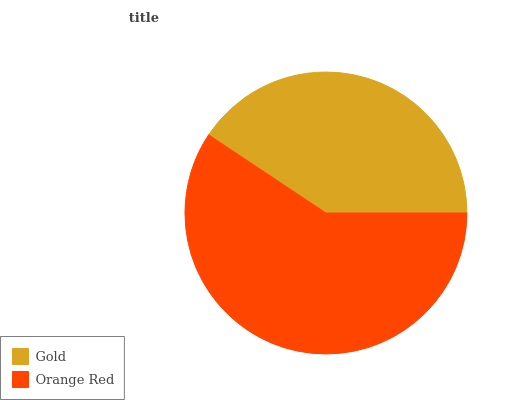Is Gold the minimum?
Answer yes or no. Yes. Is Orange Red the maximum?
Answer yes or no. Yes. Is Orange Red the minimum?
Answer yes or no. No. Is Orange Red greater than Gold?
Answer yes or no. Yes. Is Gold less than Orange Red?
Answer yes or no. Yes. Is Gold greater than Orange Red?
Answer yes or no. No. Is Orange Red less than Gold?
Answer yes or no. No. Is Orange Red the high median?
Answer yes or no. Yes. Is Gold the low median?
Answer yes or no. Yes. Is Gold the high median?
Answer yes or no. No. Is Orange Red the low median?
Answer yes or no. No. 